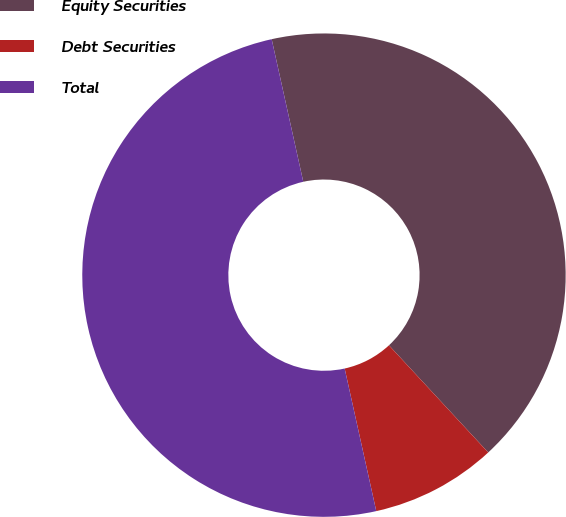Convert chart to OTSL. <chart><loc_0><loc_0><loc_500><loc_500><pie_chart><fcel>Equity Securities<fcel>Debt Securities<fcel>Total<nl><fcel>41.58%<fcel>8.42%<fcel>50.0%<nl></chart> 